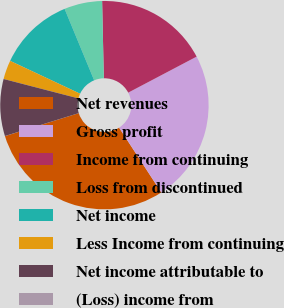Convert chart to OTSL. <chart><loc_0><loc_0><loc_500><loc_500><pie_chart><fcel>Net revenues<fcel>Gross profit<fcel>Income from continuing<fcel>Loss from discontinued<fcel>Net income<fcel>Less Income from continuing<fcel>Net income attributable to<fcel>(Loss) income from<nl><fcel>29.39%<fcel>23.52%<fcel>17.64%<fcel>5.89%<fcel>11.77%<fcel>2.95%<fcel>8.83%<fcel>0.01%<nl></chart> 